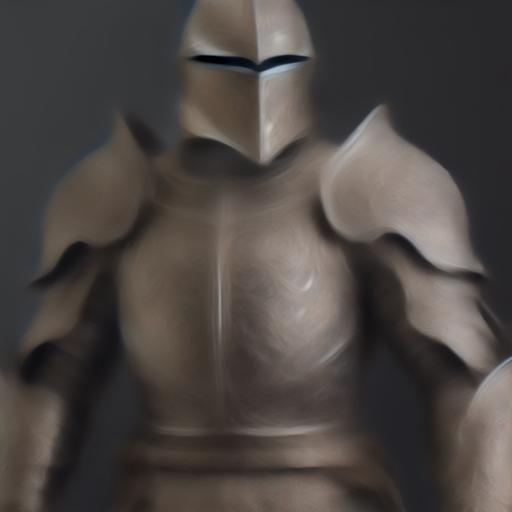What kind of emotion does this image evoke? The blurred image of the armored figure evokes a sense of mystery and intrigue. The obscured visibility can imply hidden identity or untold stories, resonating with themes of secrecy or anticipation for a revealed truth. The posture of the figure, standing confidently, might also suggest readiness or stoicism. 